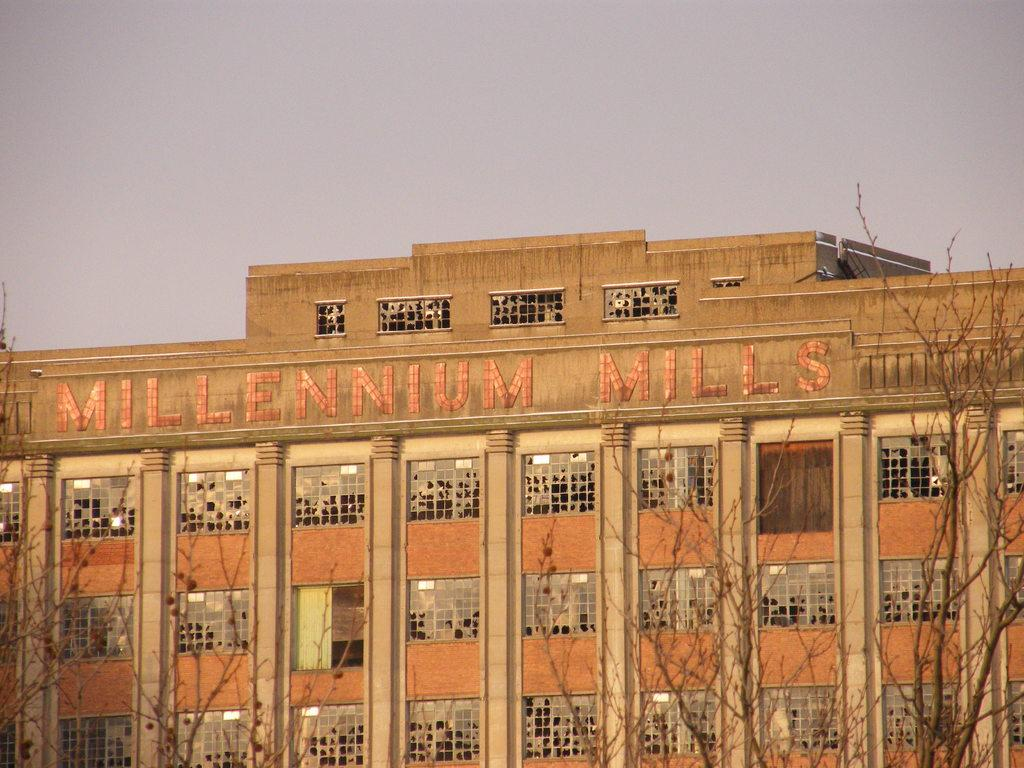What is the main subject in the center of the image? There is a building in the center of the image. What is the condition of the building's windows? The building has broken windows. What type of vegetation is present at the bottom side of the image? There are trees at the bottom side of the image. What type of drink is being served in a circle in the image? There is no drink or circle present in the image; it features a building with broken windows and trees at the bottom side. 